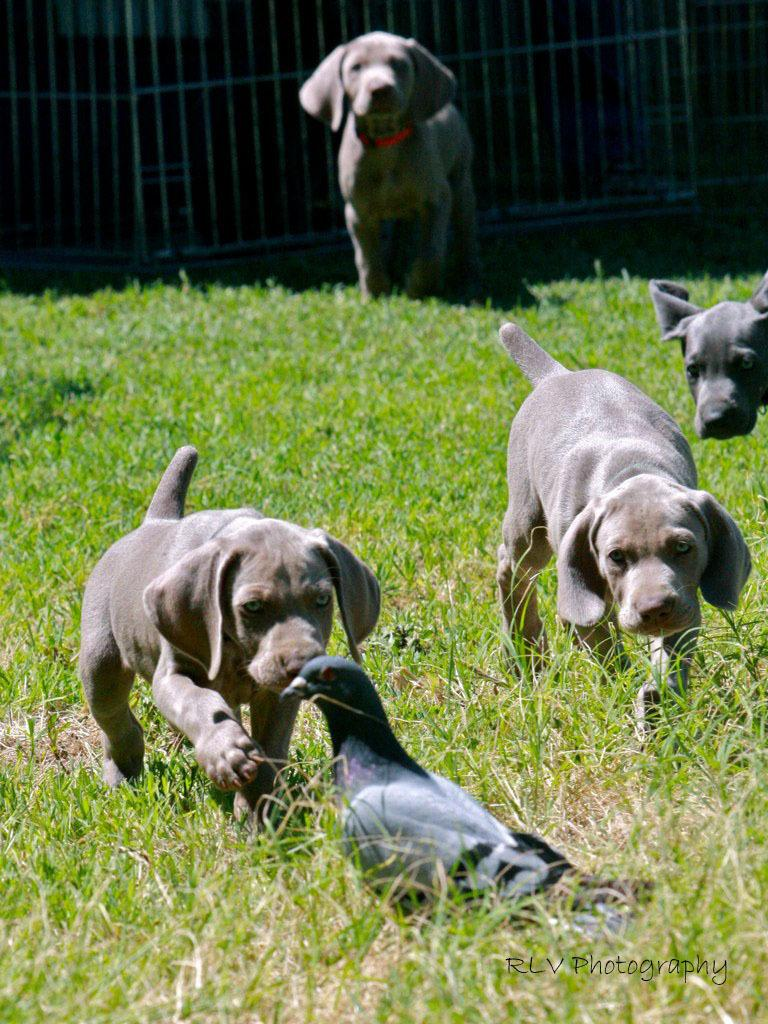How many animals can be seen in the image? There are four puppies in the image. What other animal is present in the image? There is a pigeon in the image. Where are the animals located in the image? The animals are on the ground. What type of surface can be seen on the ground in the image? There is grass visible on the ground in the image. How many times does the earth cry in the image? There is no reference to the earth or crying in the image, so this question cannot be answered. 